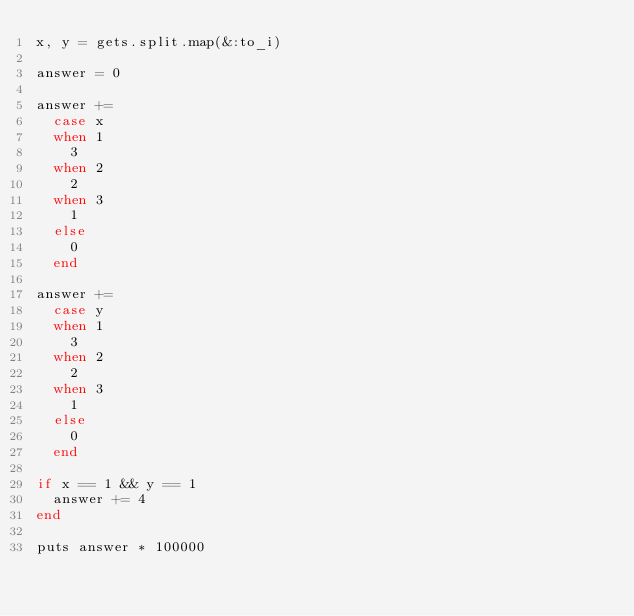Convert code to text. <code><loc_0><loc_0><loc_500><loc_500><_Ruby_>x, y = gets.split.map(&:to_i)

answer = 0

answer += 
  case x
  when 1
    3
  when 2
    2
  when 3
    1
  else
    0
  end

answer += 
  case y
  when 1
    3
  when 2
    2
  when 3
    1
  else
    0
  end

if x == 1 && y == 1
  answer += 4
end

puts answer * 100000
</code> 